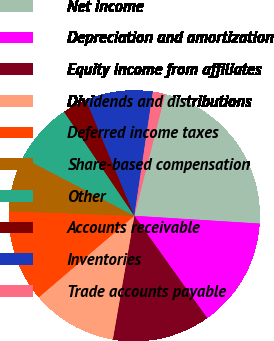<chart> <loc_0><loc_0><loc_500><loc_500><pie_chart><fcel>Net income<fcel>Depreciation and amortization<fcel>Equity income from affiliates<fcel>Dividends and distributions<fcel>Deferred income taxes<fcel>Share-based compensation<fcel>Other<fcel>Accounts receivable<fcel>Inventories<fcel>Trade accounts payable<nl><fcel>22.03%<fcel>14.17%<fcel>12.59%<fcel>11.02%<fcel>11.81%<fcel>7.09%<fcel>7.88%<fcel>3.16%<fcel>8.66%<fcel>1.59%<nl></chart> 